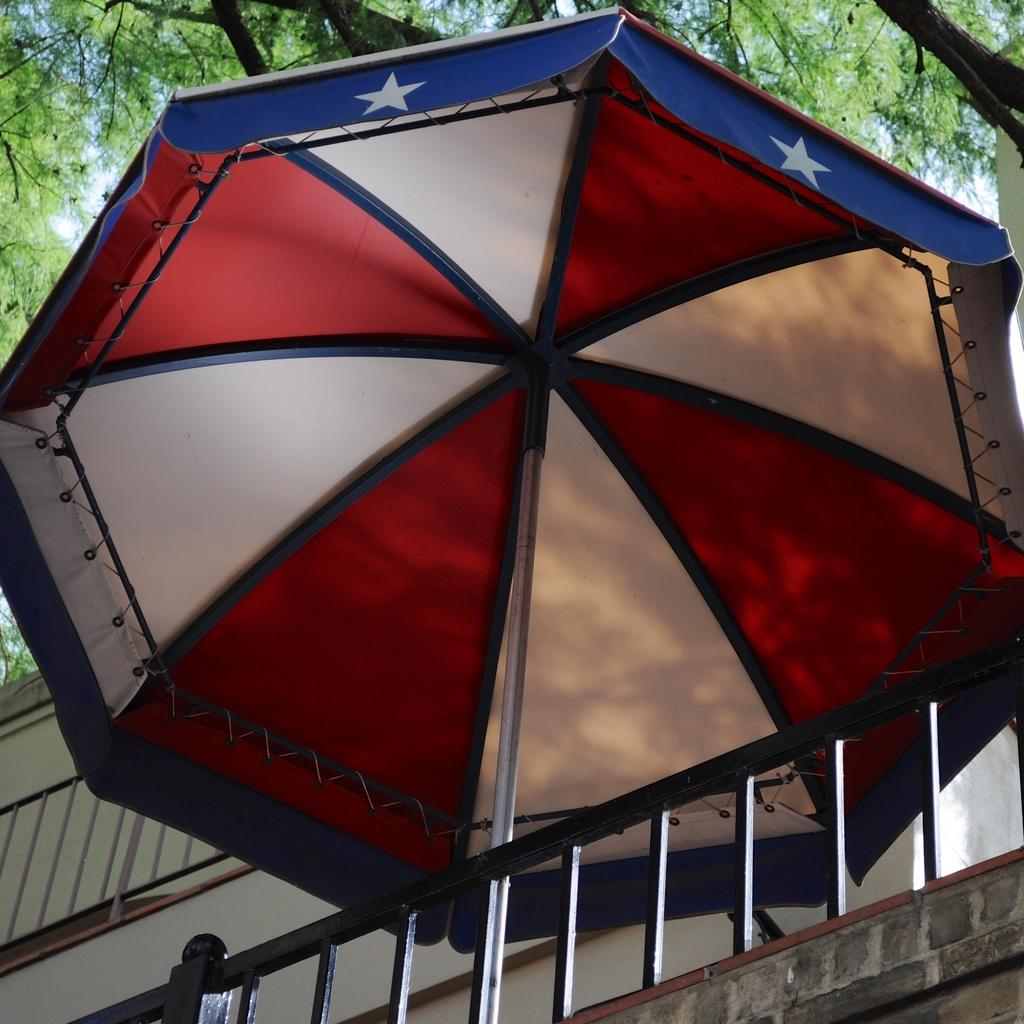What type of structure is present in the image? There is a building in the image. What object is visible that might be used for protection from the rain? There is an umbrella in the image. What type of vegetation can be seen in the image? There are trees visible in the image. What color is the sky in the image? The sky is blue in the image. Where is the mailbox located in the image? There is no mailbox present in the image. What type of river can be seen flowing through the image? There is no river present in the image. 